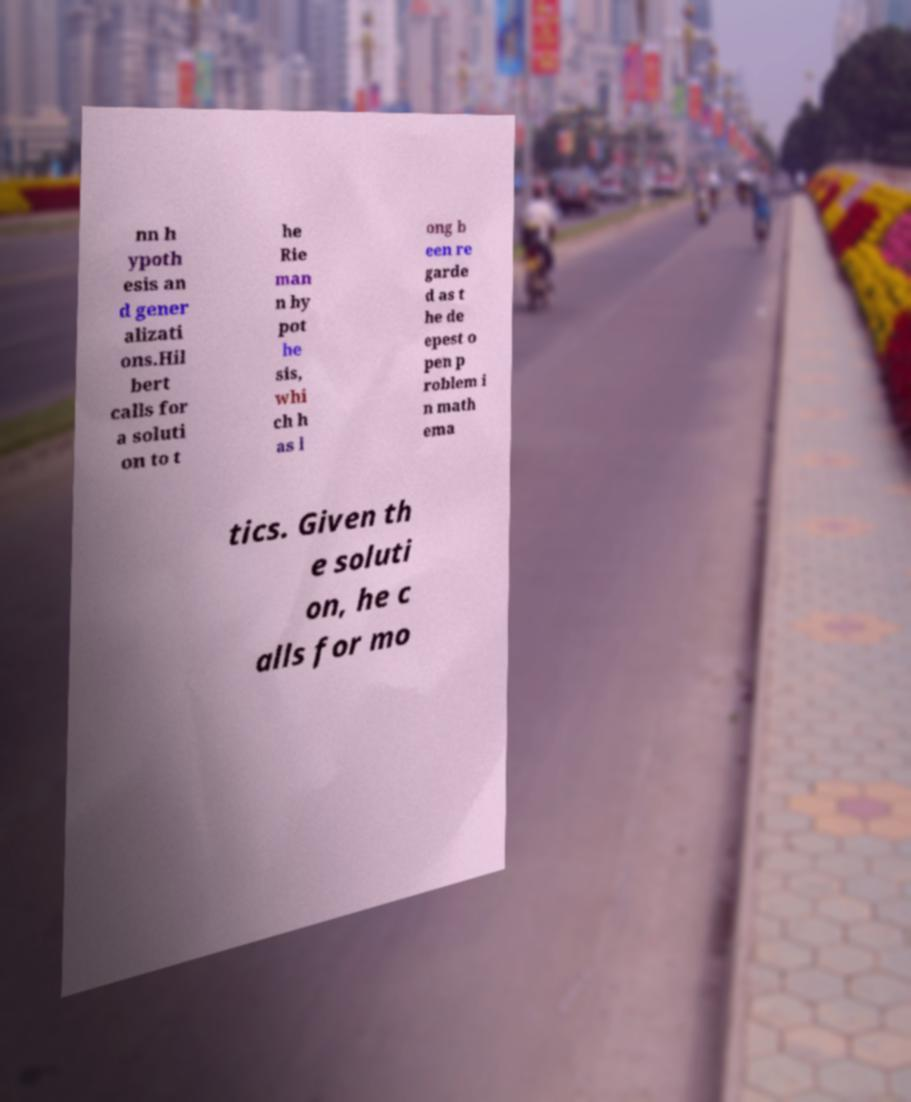Could you assist in decoding the text presented in this image and type it out clearly? nn h ypoth esis an d gener alizati ons.Hil bert calls for a soluti on to t he Rie man n hy pot he sis, whi ch h as l ong b een re garde d as t he de epest o pen p roblem i n math ema tics. Given th e soluti on, he c alls for mo 